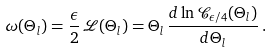<formula> <loc_0><loc_0><loc_500><loc_500>\omega ( \Theta _ { l } ) = \frac { \epsilon } { 2 } \, { \mathcal { L } } ( \Theta _ { l } ) = \Theta _ { l } \, \frac { d \ln { \mathcal { C } } _ { \epsilon / 4 } ( \Theta _ { l } ) } { d \Theta _ { l } } \, .</formula> 